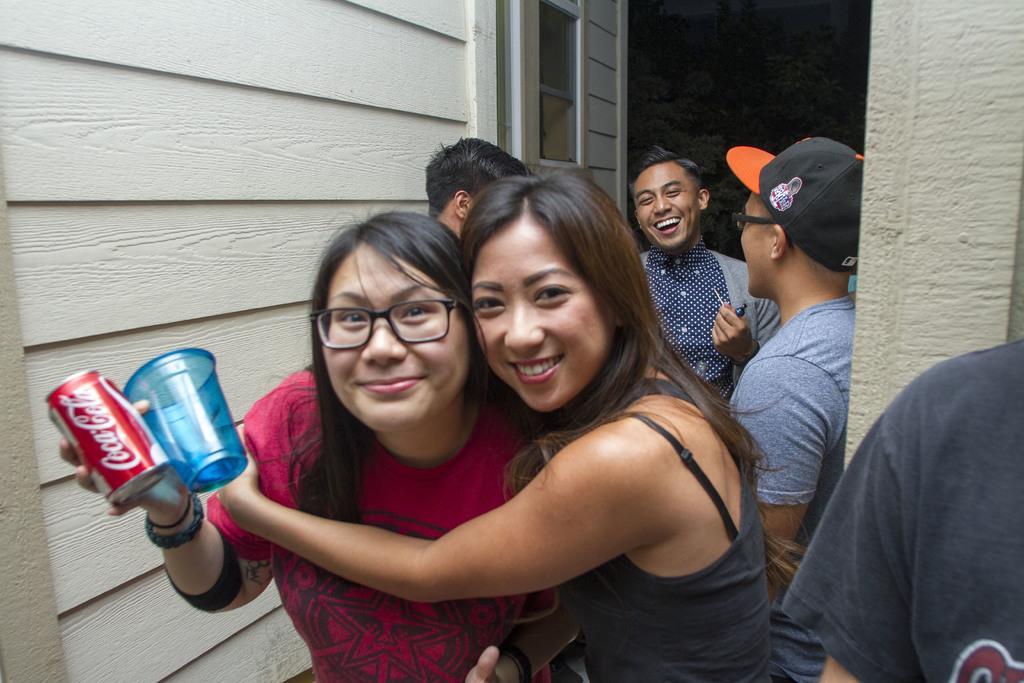Could you give a brief overview of what you see in this image? In the picture we can see two women are standing together and smiling and they are holding a glass and a tin near the wall and behind them we can see three people are standing and laughing. 